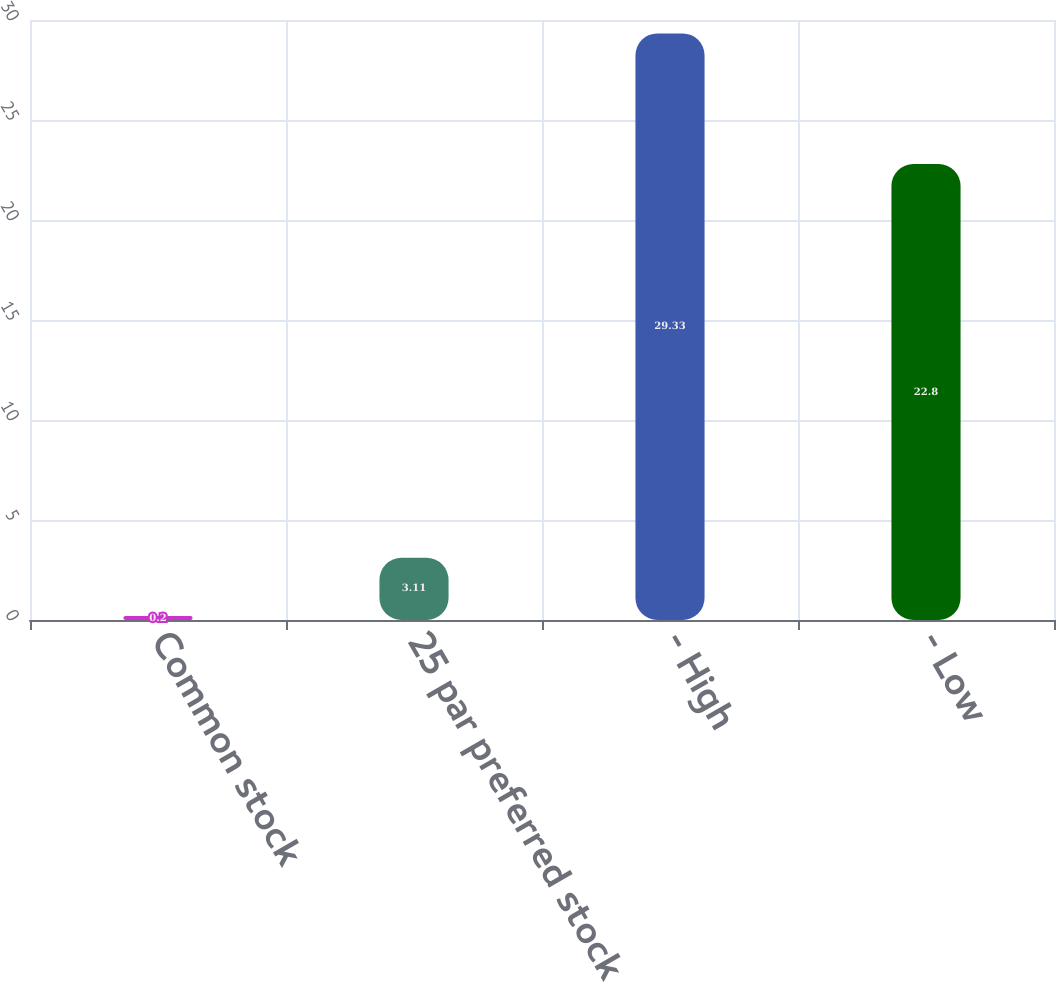Convert chart. <chart><loc_0><loc_0><loc_500><loc_500><bar_chart><fcel>Common stock<fcel>25 par preferred stock<fcel>- High<fcel>- Low<nl><fcel>0.2<fcel>3.11<fcel>29.33<fcel>22.8<nl></chart> 